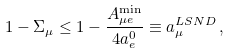Convert formula to latex. <formula><loc_0><loc_0><loc_500><loc_500>1 - \Sigma _ { \mu } \leq 1 - \frac { A _ { { \mu } e } ^ { \min } } { 4 a ^ { 0 } _ { e } } \equiv a _ { \mu } ^ { L S N D } \, ,</formula> 